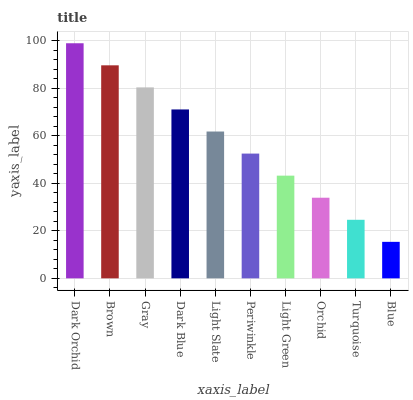Is Blue the minimum?
Answer yes or no. Yes. Is Dark Orchid the maximum?
Answer yes or no. Yes. Is Brown the minimum?
Answer yes or no. No. Is Brown the maximum?
Answer yes or no. No. Is Dark Orchid greater than Brown?
Answer yes or no. Yes. Is Brown less than Dark Orchid?
Answer yes or no. Yes. Is Brown greater than Dark Orchid?
Answer yes or no. No. Is Dark Orchid less than Brown?
Answer yes or no. No. Is Light Slate the high median?
Answer yes or no. Yes. Is Periwinkle the low median?
Answer yes or no. Yes. Is Dark Orchid the high median?
Answer yes or no. No. Is Dark Orchid the low median?
Answer yes or no. No. 